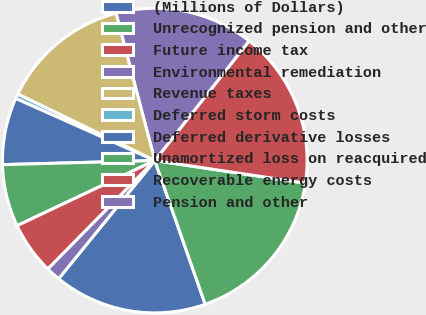Convert chart to OTSL. <chart><loc_0><loc_0><loc_500><loc_500><pie_chart><fcel>(Millions of Dollars)<fcel>Unrecognized pension and other<fcel>Future income tax<fcel>Environmental remediation<fcel>Revenue taxes<fcel>Deferred storm costs<fcel>Deferred derivative losses<fcel>Unamortized loss on reacquired<fcel>Recoverable energy costs<fcel>Pension and other<nl><fcel>16.24%<fcel>17.26%<fcel>16.75%<fcel>14.72%<fcel>13.71%<fcel>0.51%<fcel>7.11%<fcel>6.6%<fcel>5.58%<fcel>1.52%<nl></chart> 